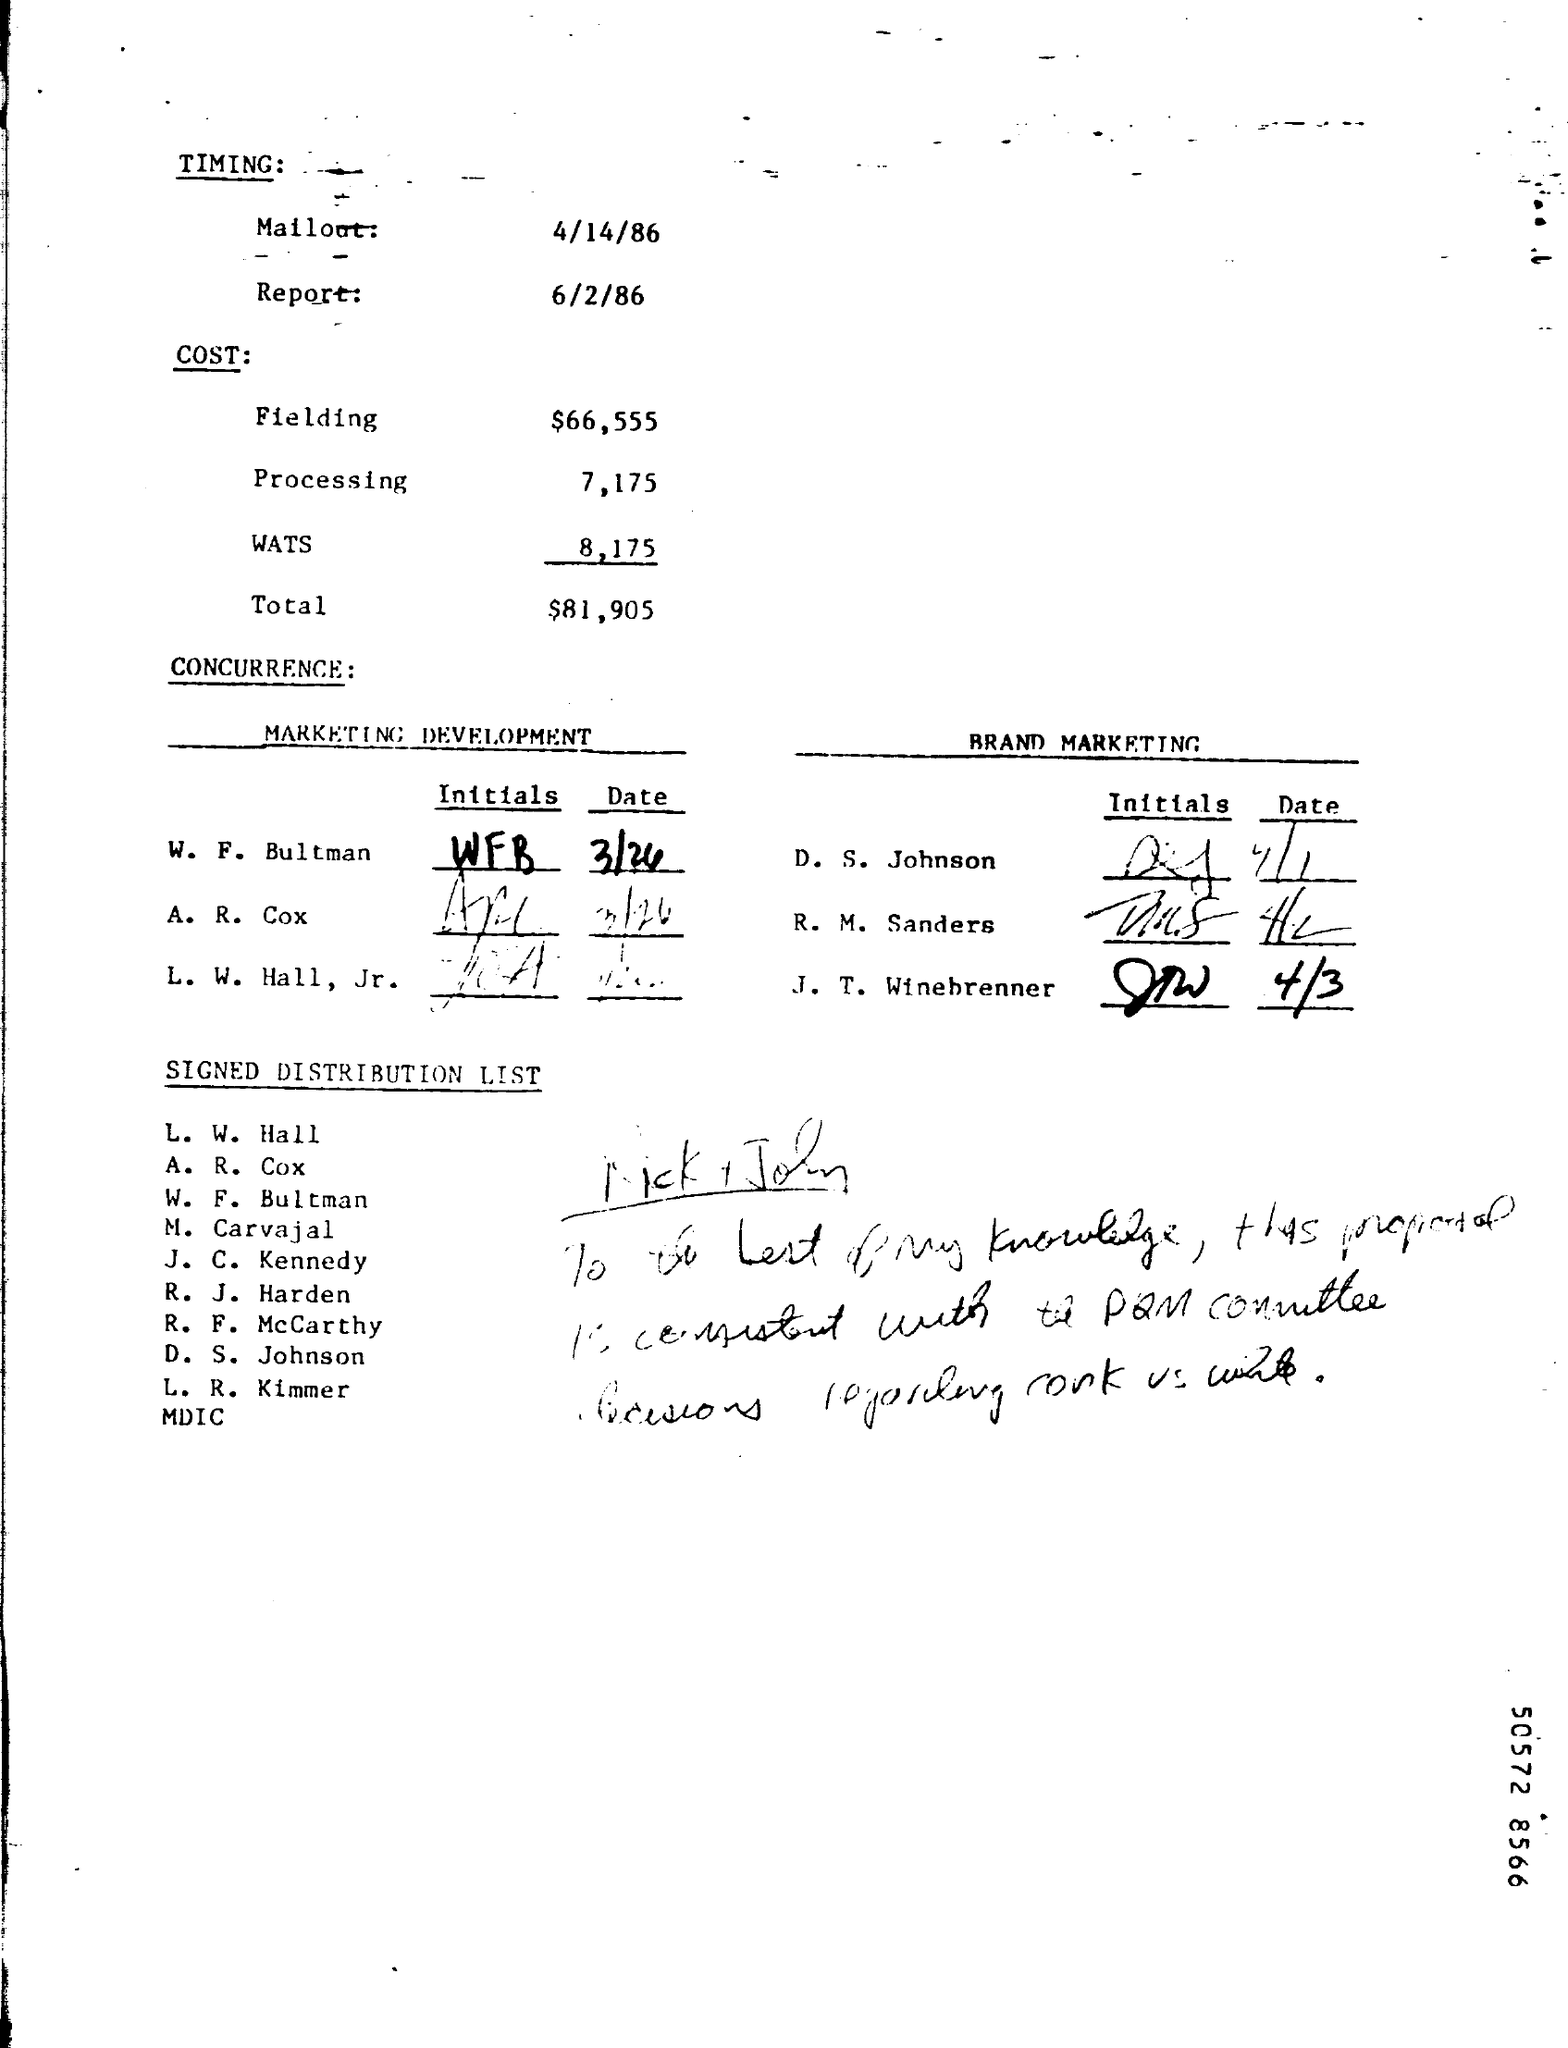Point out several critical features in this image. The fielding cost is $66,555. The timing for the report is 6/2/86. The processing cost is 7,175. The WATS cost is 8,175. The date "4/14/86" refers to April 14th, 1986. 